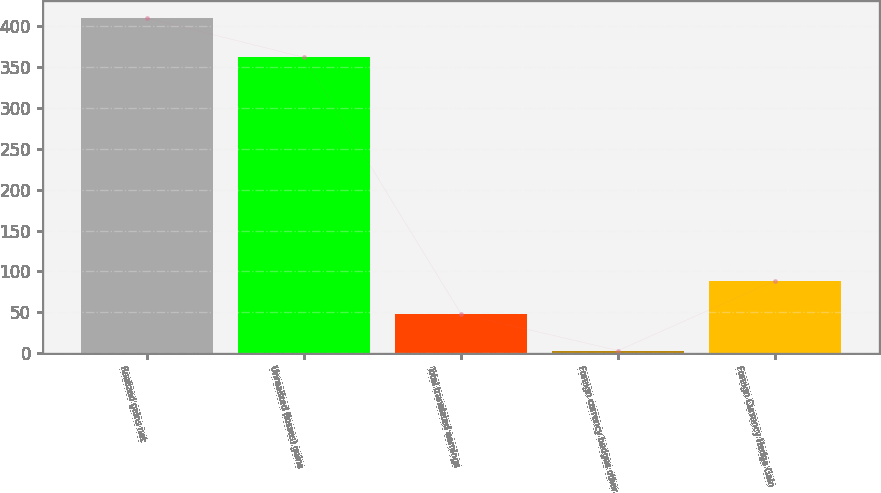Convert chart to OTSL. <chart><loc_0><loc_0><loc_500><loc_500><bar_chart><fcel>Realized gains net<fcel>Unrealized (losses) gains<fcel>Total translated earnings<fcel>Foreign currency hedges other<fcel>Foreign Currency Hedge Gain<nl><fcel>410<fcel>362<fcel>48<fcel>3<fcel>88.7<nl></chart> 